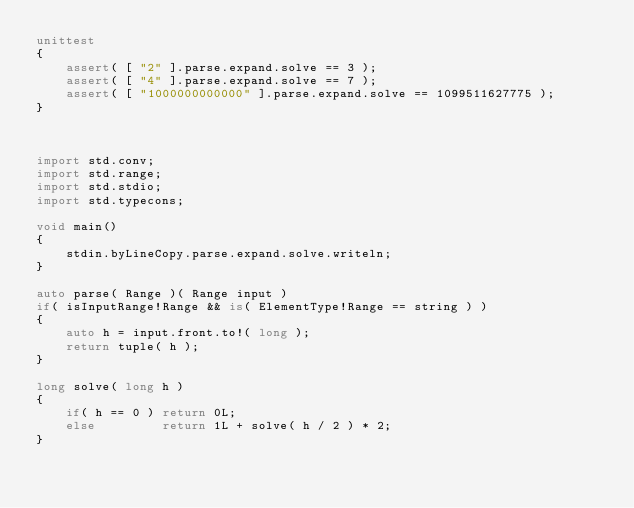Convert code to text. <code><loc_0><loc_0><loc_500><loc_500><_D_>unittest
{
	assert( [ "2" ].parse.expand.solve == 3 );
	assert( [ "4" ].parse.expand.solve == 7 );
	assert( [ "1000000000000" ].parse.expand.solve == 1099511627775 );
}



import std.conv;
import std.range;
import std.stdio;
import std.typecons;

void main()
{
	stdin.byLineCopy.parse.expand.solve.writeln;
}

auto parse( Range )( Range input )
if( isInputRange!Range && is( ElementType!Range == string ) )
{
	auto h = input.front.to!( long );
	return tuple( h );
}

long solve( long h )
{
	if( h == 0 ) return 0L;
	else         return 1L + solve( h / 2 ) * 2;
}
</code> 